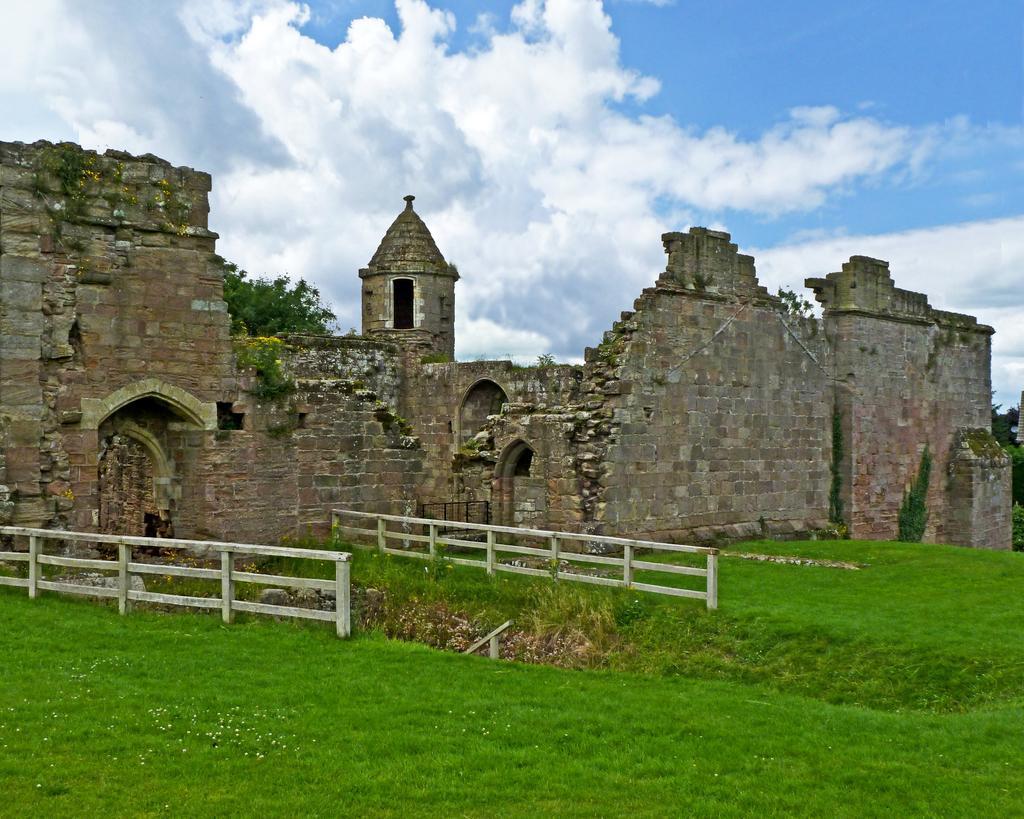Please provide a concise description of this image. In this image we can see a fort, there are some trees, fence and grass, in the background we can see the sky with clouds. 